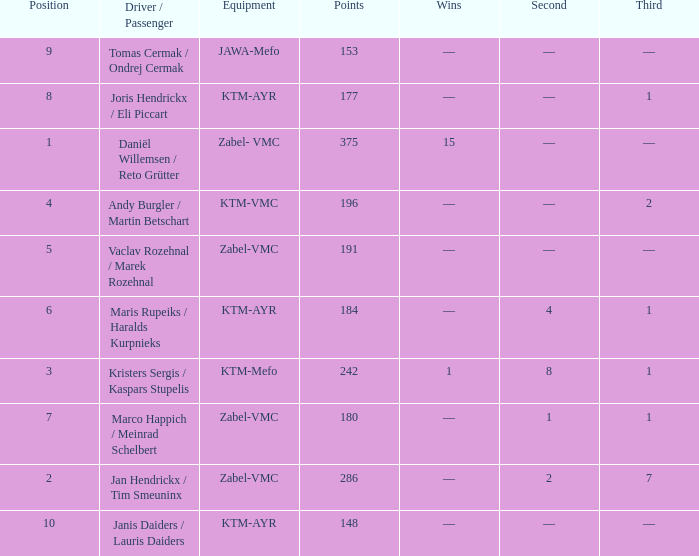Could you parse the entire table as a dict? {'header': ['Position', 'Driver / Passenger', 'Equipment', 'Points', 'Wins', 'Second', 'Third'], 'rows': [['9', 'Tomas Cermak / Ondrej Cermak', 'JAWA-Mefo', '153', '—', '—', '—'], ['8', 'Joris Hendrickx / Eli Piccart', 'KTM-AYR', '177', '—', '—', '1'], ['1', 'Daniël Willemsen / Reto Grütter', 'Zabel- VMC', '375', '15', '—', '—'], ['4', 'Andy Burgler / Martin Betschart', 'KTM-VMC', '196', '—', '—', '2'], ['5', 'Vaclav Rozehnal / Marek Rozehnal', 'Zabel-VMC', '191', '—', '—', '—'], ['6', 'Maris Rupeiks / Haralds Kurpnieks', 'KTM-AYR', '184', '—', '4', '1'], ['3', 'Kristers Sergis / Kaspars Stupelis', 'KTM-Mefo', '242', '1', '8', '1'], ['7', 'Marco Happich / Meinrad Schelbert', 'Zabel-VMC', '180', '—', '1', '1'], ['2', 'Jan Hendrickx / Tim Smeuninx', 'Zabel-VMC', '286', '—', '2', '7'], ['10', 'Janis Daiders / Lauris Daiders', 'KTM-AYR', '148', '—', '—', '—']]} What was the highest points when the second was 4? 184.0. 